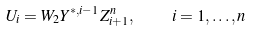<formula> <loc_0><loc_0><loc_500><loc_500>U _ { i } = W _ { 2 } Y ^ { * , i - 1 } Z _ { i + 1 } ^ { n } , \quad i = 1 , \dots , n</formula> 